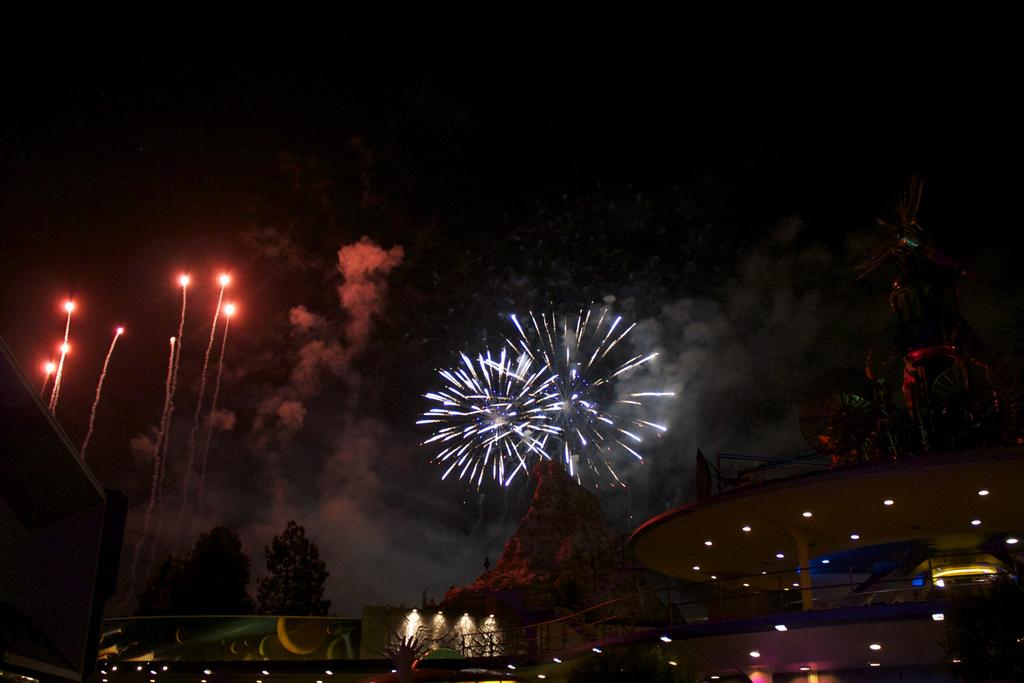What type of structure is in the image? There is a building in the image. What can be seen illuminated in the image? There are lights visible in the image. What is happening in the sky in the image? Firecrackers are present in the air. What type of vegetation is in the image? There are trees in the image. What small object is in the image? There is a small block in the image. What type of faucet is visible in the image? There is no faucet present in the image. What kind of party is being depicted in the image? The image does not depict a party; it shows a building, lights, firecrackers, trees, and a small block. 